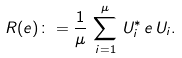Convert formula to latex. <formula><loc_0><loc_0><loc_500><loc_500>R ( e ) \colon = \frac { 1 } { \mu } \, \sum _ { i = 1 } ^ { \mu } \, U _ { i } ^ { * } \, e \, U _ { i } .</formula> 